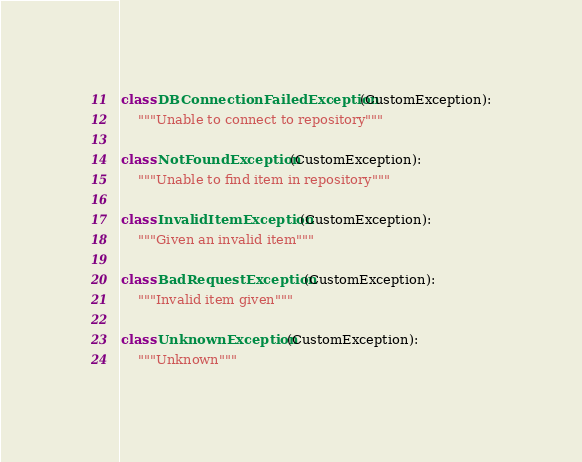<code> <loc_0><loc_0><loc_500><loc_500><_Python_>
class DBConnectionFailedException(CustomException):
    """Unable to connect to repository"""

class NotFoundException(CustomException):
    """Unable to find item in repository"""

class InvalidItemException(CustomException):
    """Given an invalid item"""

class BadRequestException(CustomException):
    """Invalid item given"""

class UnknownException(CustomException):
    """Unknown"""</code> 